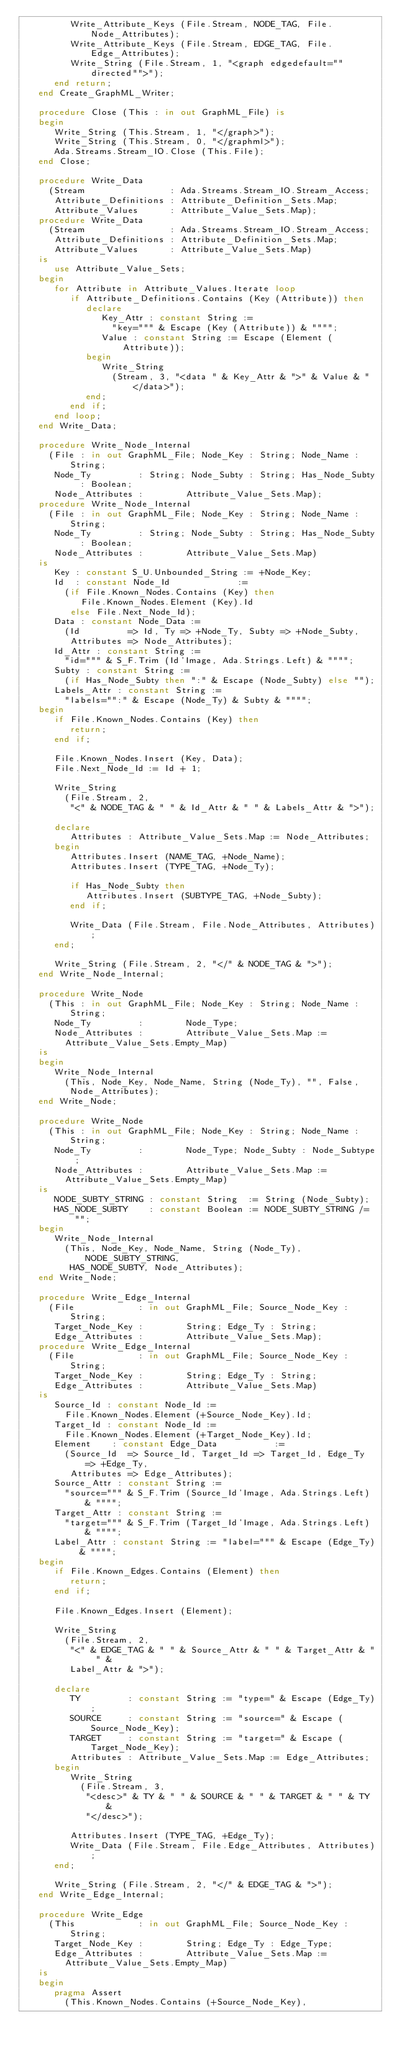Convert code to text. <code><loc_0><loc_0><loc_500><loc_500><_Ada_>         Write_Attribute_Keys (File.Stream, NODE_TAG, File.Node_Attributes);
         Write_Attribute_Keys (File.Stream, EDGE_TAG, File.Edge_Attributes);
         Write_String (File.Stream, 1, "<graph edgedefault=""directed"">");
      end return;
   end Create_GraphML_Writer;

   procedure Close (This : in out GraphML_File) is
   begin
      Write_String (This.Stream, 1, "</graph>");
      Write_String (This.Stream, 0, "</graphml>");
      Ada.Streams.Stream_IO.Close (This.File);
   end Close;

   procedure Write_Data
     (Stream                : Ada.Streams.Stream_IO.Stream_Access;
      Attribute_Definitions : Attribute_Definition_Sets.Map;
      Attribute_Values      : Attribute_Value_Sets.Map);
   procedure Write_Data
     (Stream                : Ada.Streams.Stream_IO.Stream_Access;
      Attribute_Definitions : Attribute_Definition_Sets.Map;
      Attribute_Values      : Attribute_Value_Sets.Map)
   is
      use Attribute_Value_Sets;
   begin
      for Attribute in Attribute_Values.Iterate loop
         if Attribute_Definitions.Contains (Key (Attribute)) then
            declare
               Key_Attr : constant String :=
                 "key=""" & Escape (Key (Attribute)) & """";
               Value : constant String := Escape (Element (Attribute));
            begin
               Write_String
                 (Stream, 3, "<data " & Key_Attr & ">" & Value & "</data>");
            end;
         end if;
      end loop;
   end Write_Data;

   procedure Write_Node_Internal
     (File : in out GraphML_File; Node_Key : String; Node_Name : String;
      Node_Ty         : String; Node_Subty : String; Has_Node_Subty : Boolean;
      Node_Attributes :        Attribute_Value_Sets.Map);
   procedure Write_Node_Internal
     (File : in out GraphML_File; Node_Key : String; Node_Name : String;
      Node_Ty         : String; Node_Subty : String; Has_Node_Subty : Boolean;
      Node_Attributes :        Attribute_Value_Sets.Map)
   is
      Key : constant S_U.Unbounded_String := +Node_Key;
      Id  : constant Node_Id             :=
        (if File.Known_Nodes.Contains (Key) then
           File.Known_Nodes.Element (Key).Id
         else File.Next_Node_Id);
      Data : constant Node_Data :=
        (Id         => Id, Ty => +Node_Ty, Subty => +Node_Subty,
         Attributes => Node_Attributes);
      Id_Attr : constant String :=
        "id=""" & S_F.Trim (Id'Image, Ada.Strings.Left) & """";
      Subty : constant String :=
        (if Has_Node_Subty then ":" & Escape (Node_Subty) else "");
      Labels_Attr : constant String :=
        "labels="":" & Escape (Node_Ty) & Subty & """";
   begin
      if File.Known_Nodes.Contains (Key) then
         return;
      end if;

      File.Known_Nodes.Insert (Key, Data);
      File.Next_Node_Id := Id + 1;

      Write_String
        (File.Stream, 2,
         "<" & NODE_TAG & " " & Id_Attr & " " & Labels_Attr & ">");

      declare
         Attributes : Attribute_Value_Sets.Map := Node_Attributes;
      begin
         Attributes.Insert (NAME_TAG, +Node_Name);
         Attributes.Insert (TYPE_TAG, +Node_Ty);

         if Has_Node_Subty then
            Attributes.Insert (SUBTYPE_TAG, +Node_Subty);
         end if;

         Write_Data (File.Stream, File.Node_Attributes, Attributes);
      end;

      Write_String (File.Stream, 2, "</" & NODE_TAG & ">");
   end Write_Node_Internal;

   procedure Write_Node
     (This : in out GraphML_File; Node_Key : String; Node_Name : String;
      Node_Ty         :        Node_Type;
      Node_Attributes :        Attribute_Value_Sets.Map :=
        Attribute_Value_Sets.Empty_Map)
   is
   begin
      Write_Node_Internal
        (This, Node_Key, Node_Name, String (Node_Ty), "", False,
         Node_Attributes);
   end Write_Node;

   procedure Write_Node
     (This : in out GraphML_File; Node_Key : String; Node_Name : String;
      Node_Ty         :        Node_Type; Node_Subty : Node_Subtype;
      Node_Attributes :        Attribute_Value_Sets.Map :=
        Attribute_Value_Sets.Empty_Map)
   is
      NODE_SUBTY_STRING : constant String  := String (Node_Subty);
      HAS_NODE_SUBTY    : constant Boolean := NODE_SUBTY_STRING /= "";
   begin
      Write_Node_Internal
        (This, Node_Key, Node_Name, String (Node_Ty), NODE_SUBTY_STRING,
         HAS_NODE_SUBTY, Node_Attributes);
   end Write_Node;

   procedure Write_Edge_Internal
     (File            : in out GraphML_File; Source_Node_Key : String;
      Target_Node_Key :        String; Edge_Ty : String;
      Edge_Attributes :        Attribute_Value_Sets.Map);
   procedure Write_Edge_Internal
     (File            : in out GraphML_File; Source_Node_Key : String;
      Target_Node_Key :        String; Edge_Ty : String;
      Edge_Attributes :        Attribute_Value_Sets.Map)
   is
      Source_Id : constant Node_Id :=
        File.Known_Nodes.Element (+Source_Node_Key).Id;
      Target_Id : constant Node_Id :=
        File.Known_Nodes.Element (+Target_Node_Key).Id;
      Element    : constant Edge_Data           :=
        (Source_Id  => Source_Id, Target_Id => Target_Id, Edge_Ty => +Edge_Ty,
         Attributes => Edge_Attributes);
      Source_Attr : constant String :=
        "source=""" & S_F.Trim (Source_Id'Image, Ada.Strings.Left) & """";
      Target_Attr : constant String :=
        "target=""" & S_F.Trim (Target_Id'Image, Ada.Strings.Left) & """";
      Label_Attr : constant String := "label=""" & Escape (Edge_Ty) & """";
   begin
      if File.Known_Edges.Contains (Element) then
         return;
      end if;

      File.Known_Edges.Insert (Element);

      Write_String
        (File.Stream, 2,
         "<" & EDGE_TAG & " " & Source_Attr & " " & Target_Attr & " " &
         Label_Attr & ">");

      declare
         TY         : constant String := "type=" & Escape (Edge_Ty);
         SOURCE     : constant String := "source=" & Escape (Source_Node_Key);
         TARGET     : constant String := "target=" & Escape (Target_Node_Key);
         Attributes : Attribute_Value_Sets.Map := Edge_Attributes;
      begin
         Write_String
           (File.Stream, 3,
            "<desc>" & TY & " " & SOURCE & " " & TARGET & " " & TY &
            "</desc>");

         Attributes.Insert (TYPE_TAG, +Edge_Ty);
         Write_Data (File.Stream, File.Edge_Attributes, Attributes);
      end;

      Write_String (File.Stream, 2, "</" & EDGE_TAG & ">");
   end Write_Edge_Internal;

   procedure Write_Edge
     (This            : in out GraphML_File; Source_Node_Key : String;
      Target_Node_Key :        String; Edge_Ty : Edge_Type;
      Edge_Attributes :        Attribute_Value_Sets.Map :=
        Attribute_Value_Sets.Empty_Map)
   is
   begin
      pragma Assert
        (This.Known_Nodes.Contains (+Source_Node_Key),</code> 